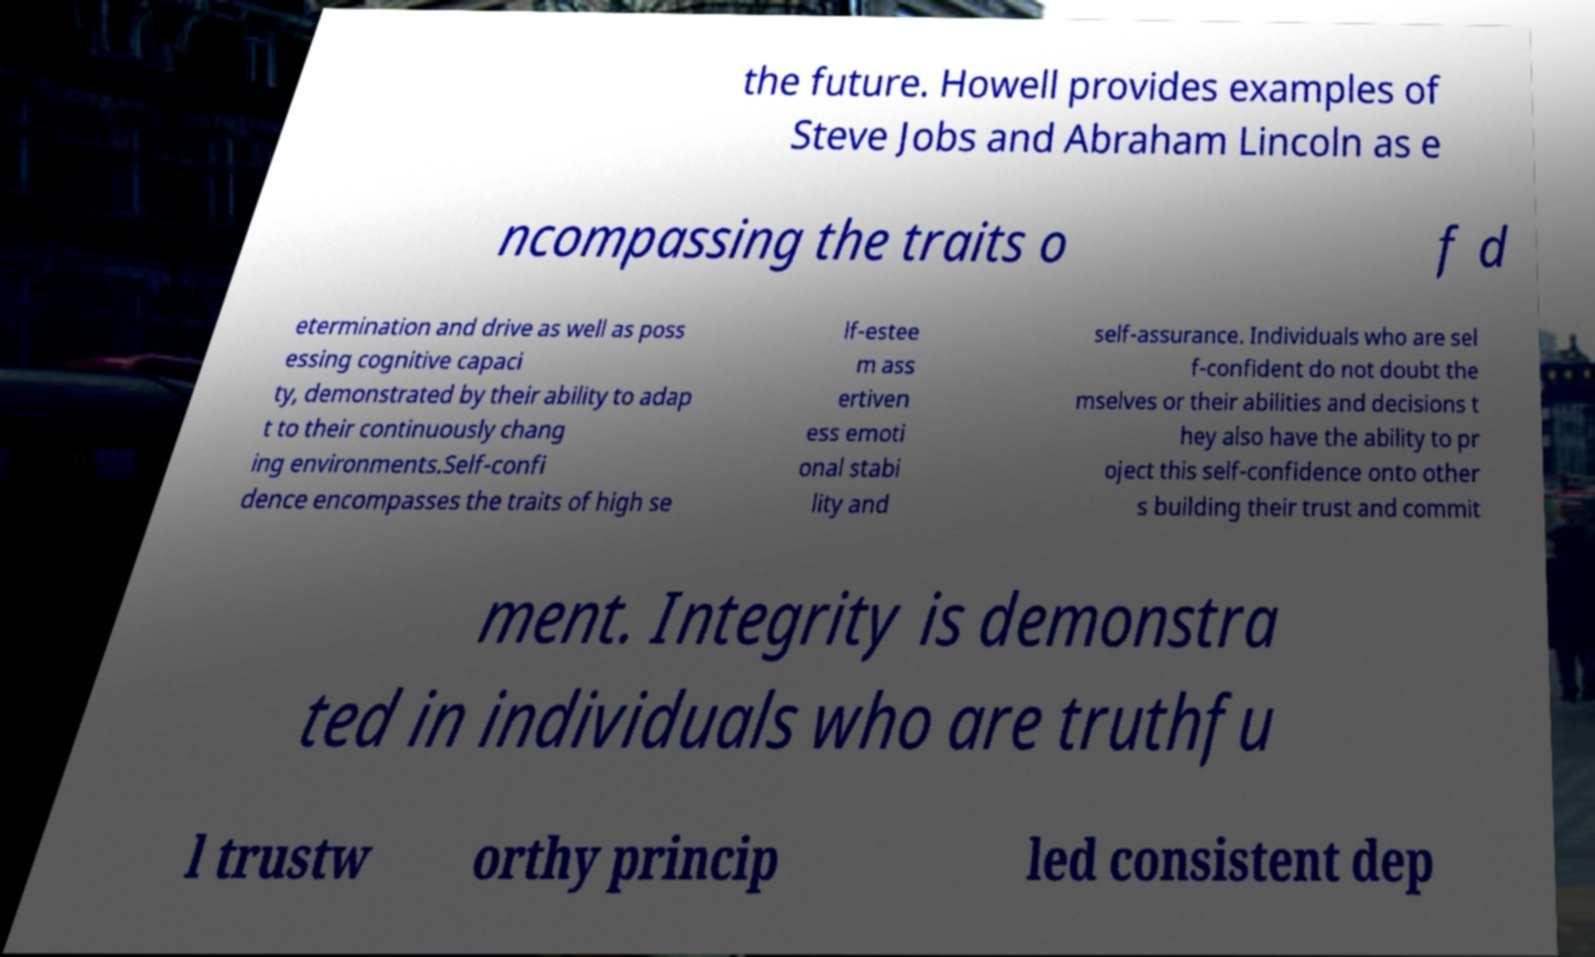Can you read and provide the text displayed in the image?This photo seems to have some interesting text. Can you extract and type it out for me? the future. Howell provides examples of Steve Jobs and Abraham Lincoln as e ncompassing the traits o f d etermination and drive as well as poss essing cognitive capaci ty, demonstrated by their ability to adap t to their continuously chang ing environments.Self-confi dence encompasses the traits of high se lf-estee m ass ertiven ess emoti onal stabi lity and self-assurance. Individuals who are sel f-confident do not doubt the mselves or their abilities and decisions t hey also have the ability to pr oject this self-confidence onto other s building their trust and commit ment. Integrity is demonstra ted in individuals who are truthfu l trustw orthy princip led consistent dep 